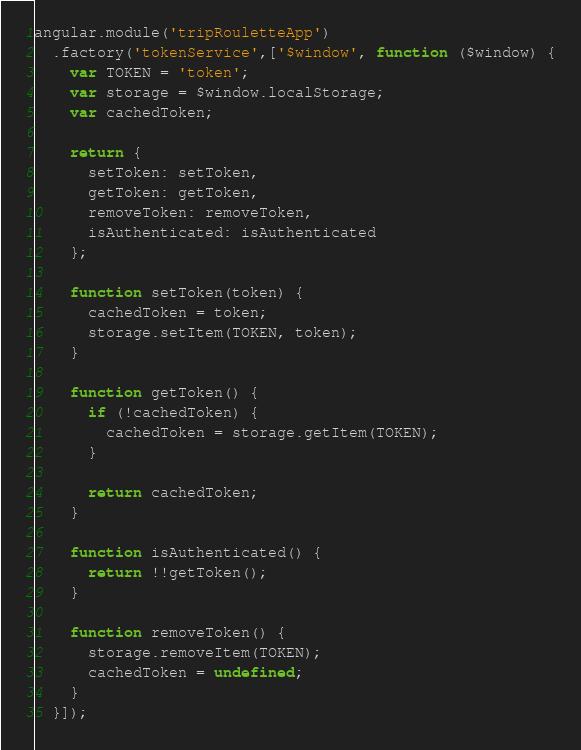Convert code to text. <code><loc_0><loc_0><loc_500><loc_500><_JavaScript_>angular.module('tripRouletteApp')
  .factory('tokenService',['$window', function ($window) {
    var TOKEN = 'token';
    var storage = $window.localStorage;
    var cachedToken;

    return {
      setToken: setToken,
      getToken: getToken,
      removeToken: removeToken,
      isAuthenticated: isAuthenticated
    };

    function setToken(token) {
      cachedToken = token;
      storage.setItem(TOKEN, token);
    }

    function getToken() {
      if (!cachedToken) {
        cachedToken = storage.getItem(TOKEN);
      }

      return cachedToken;
    }

    function isAuthenticated() {
      return !!getToken();
    }

    function removeToken() {
      storage.removeItem(TOKEN);
      cachedToken = undefined;
    }
  }]);</code> 